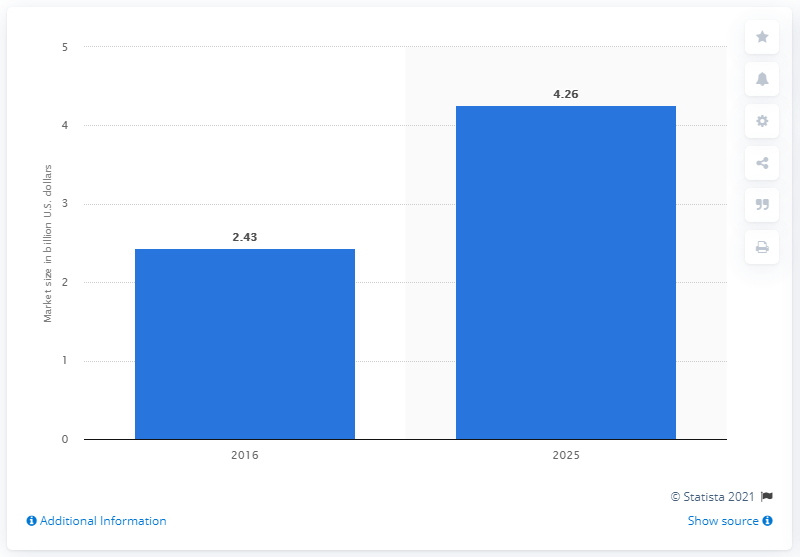Highlight a few significant elements in this photo. The value of 2025 bar data is 4.26. The estimated value of the global medical imaging analytics software market by 2025 is 4.26. The average of two bars is 6.69. The forecast for the global medical imaging analytics software market is for the year 2025. 